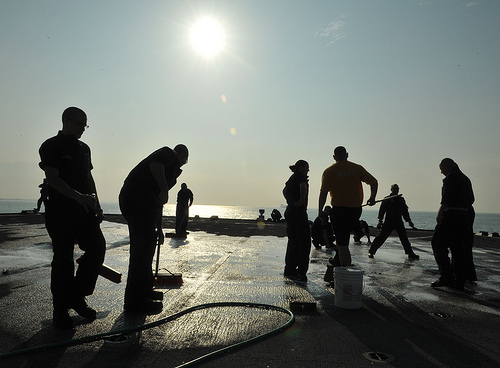<image>
Is the man in front of the bucket? No. The man is not in front of the bucket. The spatial positioning shows a different relationship between these objects. 